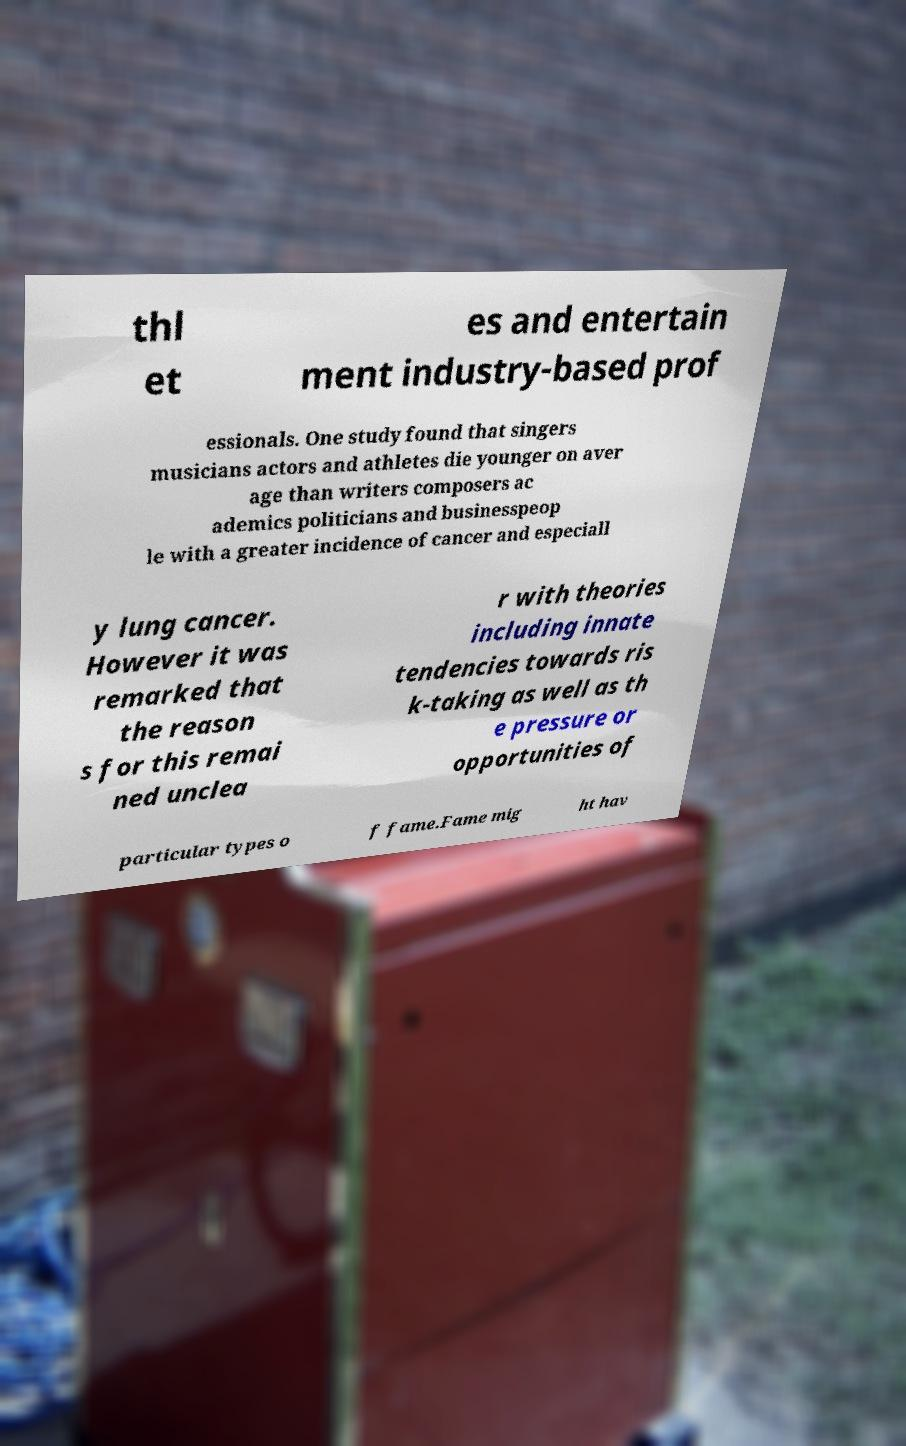Can you accurately transcribe the text from the provided image for me? thl et es and entertain ment industry-based prof essionals. One study found that singers musicians actors and athletes die younger on aver age than writers composers ac ademics politicians and businesspeop le with a greater incidence of cancer and especiall y lung cancer. However it was remarked that the reason s for this remai ned unclea r with theories including innate tendencies towards ris k-taking as well as th e pressure or opportunities of particular types o f fame.Fame mig ht hav 